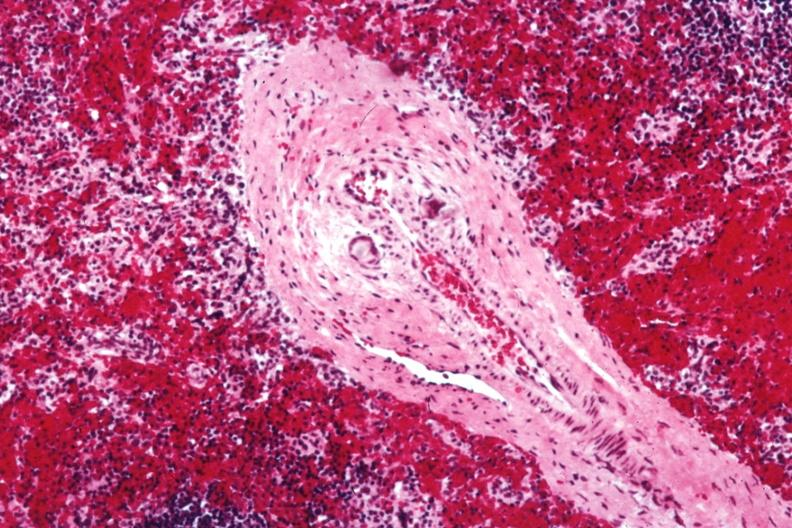s anencephaly and bilateral cleft palate present?
Answer the question using a single word or phrase. No 